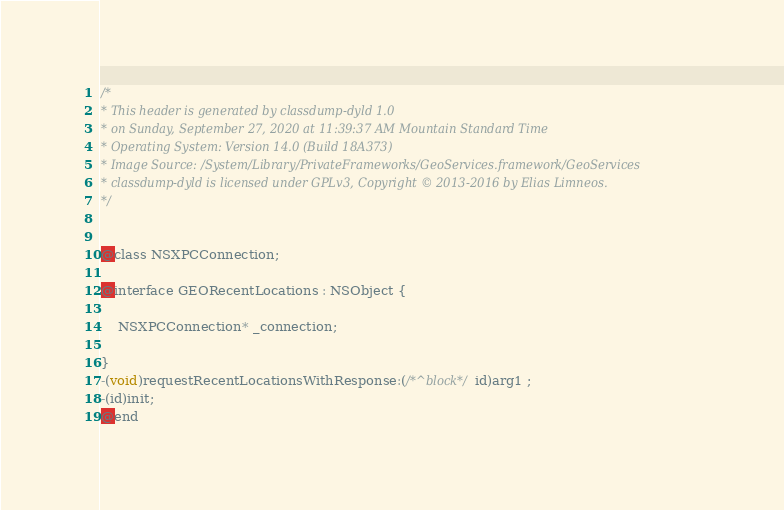Convert code to text. <code><loc_0><loc_0><loc_500><loc_500><_C_>/*
* This header is generated by classdump-dyld 1.0
* on Sunday, September 27, 2020 at 11:39:37 AM Mountain Standard Time
* Operating System: Version 14.0 (Build 18A373)
* Image Source: /System/Library/PrivateFrameworks/GeoServices.framework/GeoServices
* classdump-dyld is licensed under GPLv3, Copyright © 2013-2016 by Elias Limneos.
*/


@class NSXPCConnection;

@interface GEORecentLocations : NSObject {

	NSXPCConnection* _connection;

}
-(void)requestRecentLocationsWithResponse:(/*^block*/id)arg1 ;
-(id)init;
@end

</code> 